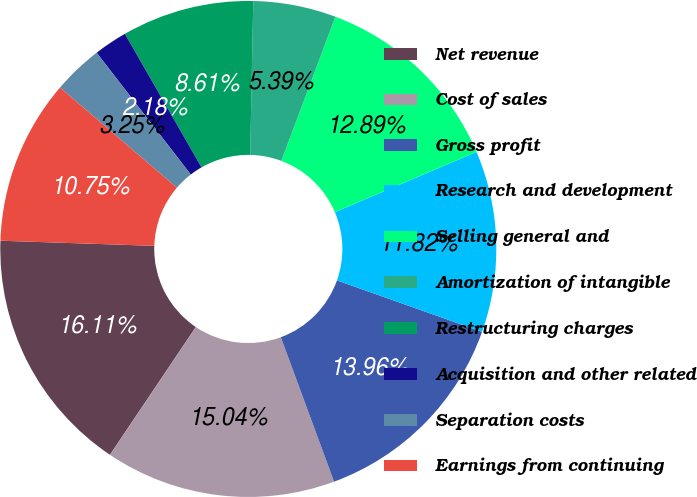<chart> <loc_0><loc_0><loc_500><loc_500><pie_chart><fcel>Net revenue<fcel>Cost of sales<fcel>Gross profit<fcel>Research and development<fcel>Selling general and<fcel>Amortization of intangible<fcel>Restructuring charges<fcel>Acquisition and other related<fcel>Separation costs<fcel>Earnings from continuing<nl><fcel>16.11%<fcel>15.04%<fcel>13.96%<fcel>11.82%<fcel>12.89%<fcel>5.39%<fcel>8.61%<fcel>2.18%<fcel>3.25%<fcel>10.75%<nl></chart> 